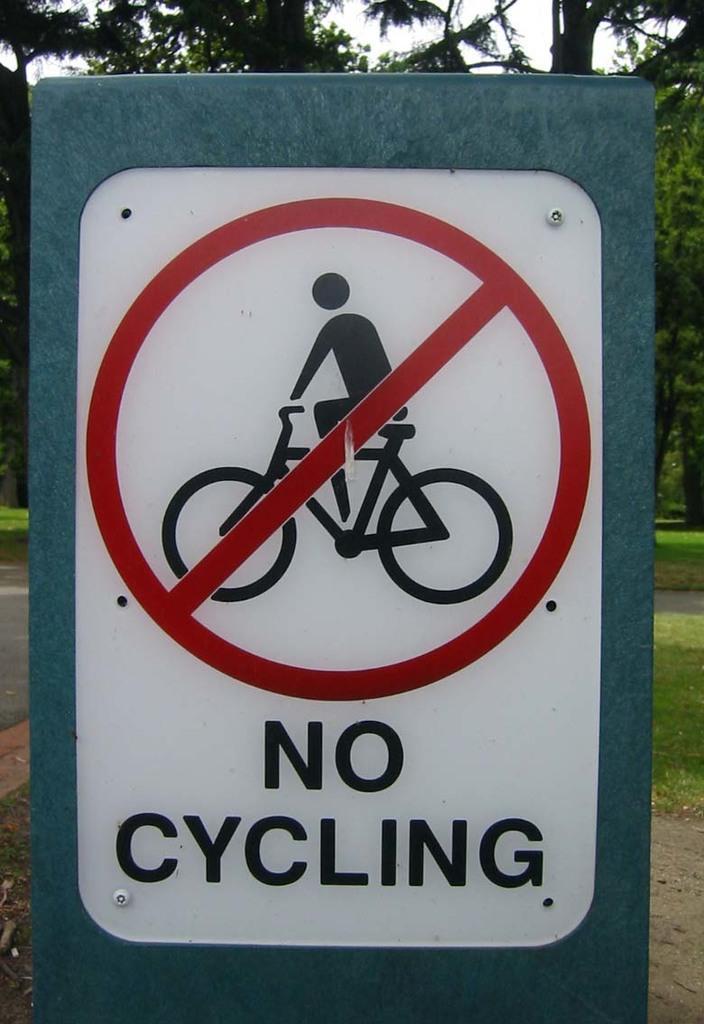How would you summarize this image in a sentence or two? In the image we can see the instruction board, on it we can see some text and the symbol. Here we can see grass, trees and the sky. 